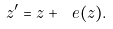<formula> <loc_0><loc_0><loc_500><loc_500>z ^ { \prime } = z + \ e ( z ) .</formula> 